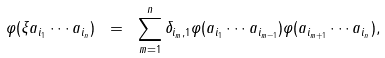Convert formula to latex. <formula><loc_0><loc_0><loc_500><loc_500>\varphi ( \xi a _ { i _ { 1 } } \cdots a _ { i _ { n } } ) \ = \ \sum _ { m = 1 } ^ { n } \delta _ { i _ { m } , 1 } \varphi ( a _ { i _ { 1 } } \cdots a _ { i _ { m - 1 } } ) \varphi ( a _ { i _ { m + 1 } } \cdots a _ { i _ { n } } ) ,</formula> 